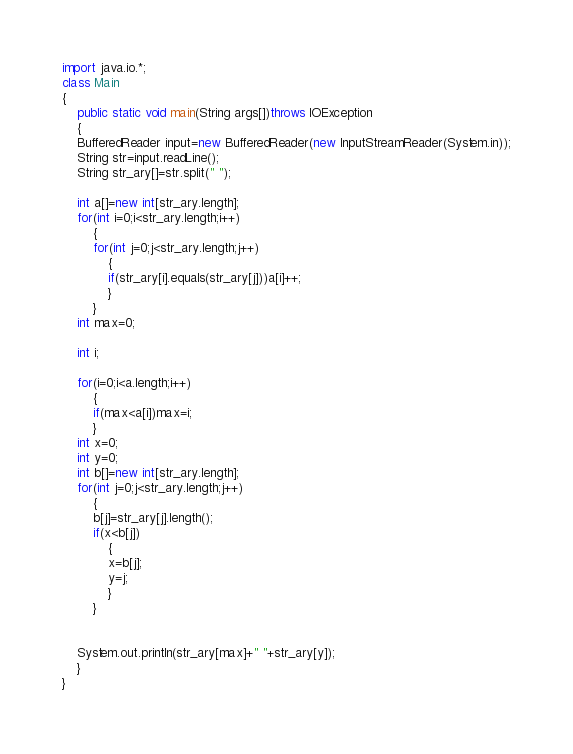<code> <loc_0><loc_0><loc_500><loc_500><_Java_>import java.io.*;
class Main
{
    public static void main(String args[])throws IOException
    {
	BufferedReader input=new BufferedReader(new InputStreamReader(System.in));
	String str=input.readLine();
	String str_ary[]=str.split(" ");
	
	int a[]=new int[str_ary.length];
	for(int i=0;i<str_ary.length;i++)
	    {
		for(int j=0;j<str_ary.length;j++)
		    {
			if(str_ary[i].equals(str_ary[j]))a[i]++;
		    }
	    }
	int max=0;

	int i;
	
	for(i=0;i<a.length;i++)
	    {
		if(max<a[i])max=i;
	    }
	int x=0;
	int y=0;
	int b[]=new int[str_ary.length];
	for(int j=0;j<str_ary.length;j++)
	    {
		b[j]=str_ary[j].length();
		if(x<b[j])
		    {
			x=b[j];
			y=j;
		    }
	    }
	
	
	System.out.println(str_ary[max]+" "+str_ary[y]);
    }
}</code> 